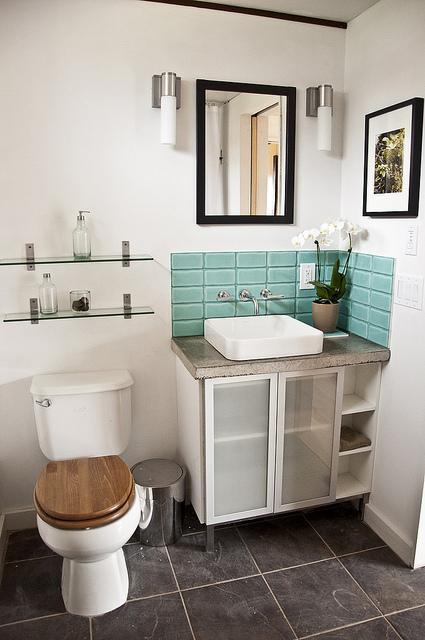How many sinks are there?
Give a very brief answer. 1. 